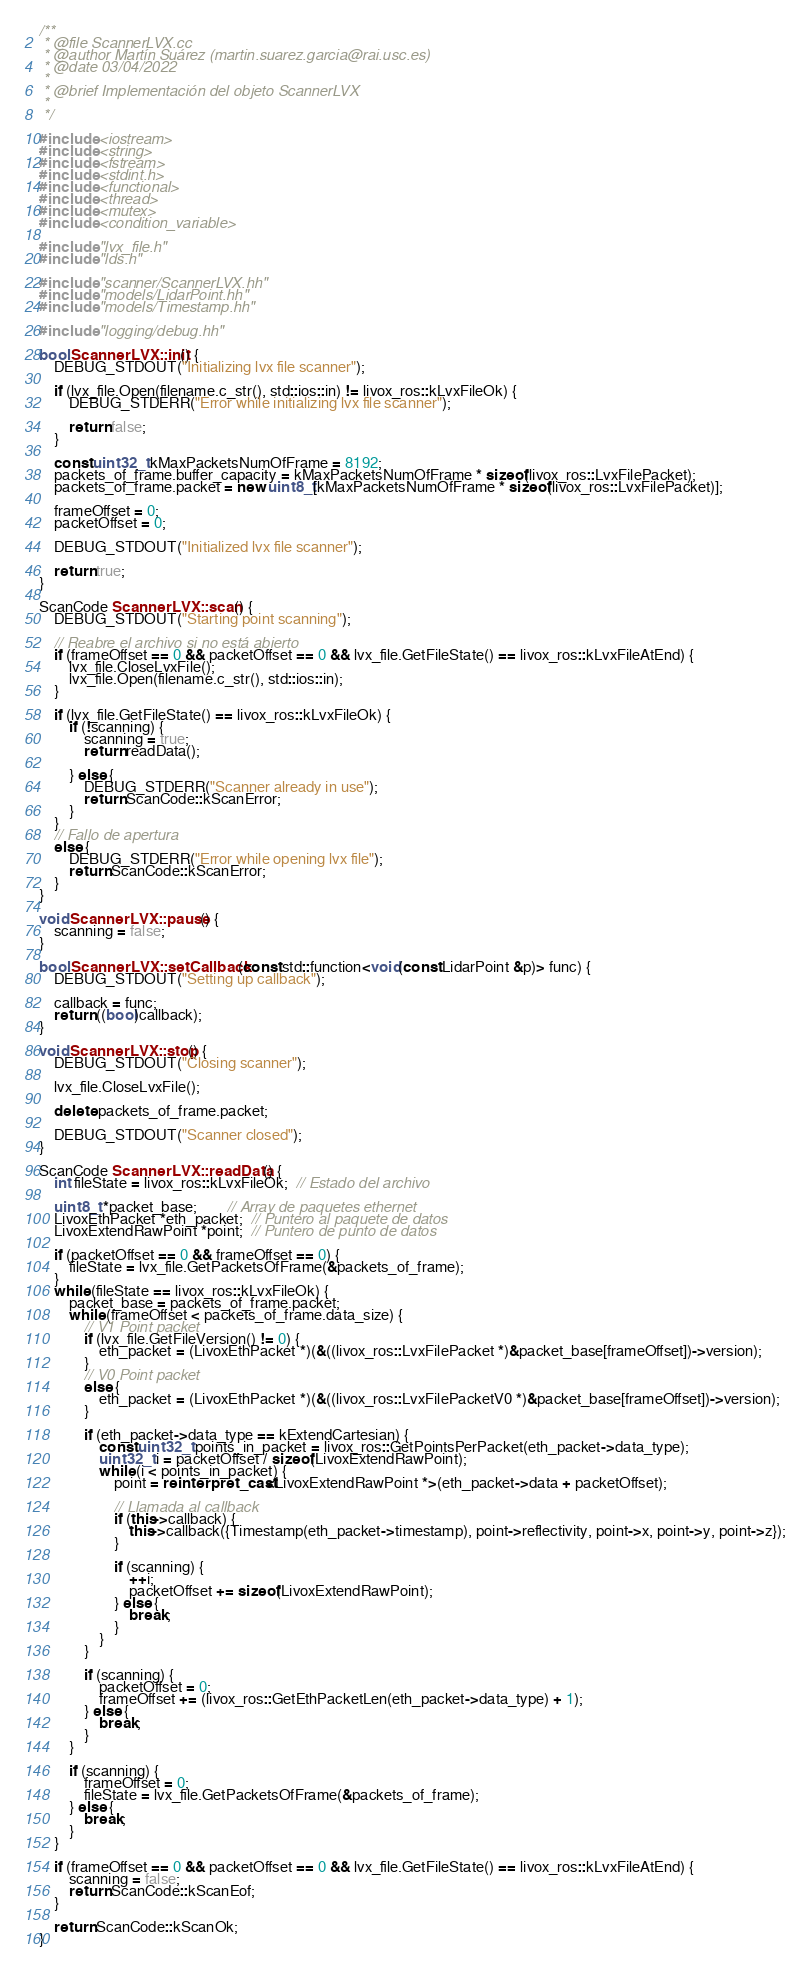Convert code to text. <code><loc_0><loc_0><loc_500><loc_500><_C++_>/**
 * @file ScannerLVX.cc
 * @author Martín Suárez (martin.suarez.garcia@rai.usc.es)
 * @date 03/04/2022
 *
 * @brief Implementación del objeto ScannerLVX
 *
 */

#include <iostream>
#include <string>
#include <fstream>
#include <stdint.h>
#include <functional>
#include <thread>
#include <mutex>
#include <condition_variable>

#include "lvx_file.h"
#include "lds.h"

#include "scanner/ScannerLVX.hh"
#include "models/LidarPoint.hh"
#include "models/Timestamp.hh"

#include "logging/debug.hh"

bool ScannerLVX::init() {
    DEBUG_STDOUT("Initializing lvx file scanner");

    if (lvx_file.Open(filename.c_str(), std::ios::in) != livox_ros::kLvxFileOk) {
        DEBUG_STDERR("Error while initializing lvx file scanner");

        return false;
    }

    const uint32_t kMaxPacketsNumOfFrame = 8192;
    packets_of_frame.buffer_capacity = kMaxPacketsNumOfFrame * sizeof(livox_ros::LvxFilePacket);
    packets_of_frame.packet = new uint8_t[kMaxPacketsNumOfFrame * sizeof(livox_ros::LvxFilePacket)];

    frameOffset = 0;
    packetOffset = 0;

    DEBUG_STDOUT("Initialized lvx file scanner");

    return true;
}

ScanCode ScannerLVX::scan() {
    DEBUG_STDOUT("Starting point scanning");

    // Reabre el archivo si no está abierto
    if (frameOffset == 0 && packetOffset == 0 && lvx_file.GetFileState() == livox_ros::kLvxFileAtEnd) {
        lvx_file.CloseLvxFile();
        lvx_file.Open(filename.c_str(), std::ios::in);
    }

    if (lvx_file.GetFileState() == livox_ros::kLvxFileOk) {
        if (!scanning) {
            scanning = true;
            return readData();

        } else {
            DEBUG_STDERR("Scanner already in use");
            return ScanCode::kScanError;
        }
    }
    // Fallo de apertura
    else {
        DEBUG_STDERR("Error while opening lvx file");
        return ScanCode::kScanError;
    }
}

void ScannerLVX::pause() {
    scanning = false;
}

bool ScannerLVX::setCallback(const std::function<void(const LidarPoint &p)> func) {
    DEBUG_STDOUT("Setting up callback");

    callback = func;
    return ((bool)callback);
}

void ScannerLVX::stop() {
    DEBUG_STDOUT("Closing scanner");

    lvx_file.CloseLvxFile();

    delete packets_of_frame.packet;

    DEBUG_STDOUT("Scanner closed");
}

ScanCode ScannerLVX::readData() {
    int fileState = livox_ros::kLvxFileOk;  // Estado del archivo

    uint8_t *packet_base;        // Array de paquetes ethernet
    LivoxEthPacket *eth_packet;  // Puntero al paquete de datos
    LivoxExtendRawPoint *point;  // Puntero de punto de datos

    if (packetOffset == 0 && frameOffset == 0) {
        fileState = lvx_file.GetPacketsOfFrame(&packets_of_frame);
    }
    while (fileState == livox_ros::kLvxFileOk) {
        packet_base = packets_of_frame.packet;
        while (frameOffset < packets_of_frame.data_size) {
            // V1 Point packet
            if (lvx_file.GetFileVersion() != 0) {
                eth_packet = (LivoxEthPacket *)(&((livox_ros::LvxFilePacket *)&packet_base[frameOffset])->version);
            }
            // V0 Point packet
            else {
                eth_packet = (LivoxEthPacket *)(&((livox_ros::LvxFilePacketV0 *)&packet_base[frameOffset])->version);
            }

            if (eth_packet->data_type == kExtendCartesian) {
                const uint32_t points_in_packet = livox_ros::GetPointsPerPacket(eth_packet->data_type);
                uint32_t i = packetOffset / sizeof(LivoxExtendRawPoint);
                while (i < points_in_packet) {
                    point = reinterpret_cast<LivoxExtendRawPoint *>(eth_packet->data + packetOffset);

                    // Llamada al callback
                    if (this->callback) {
                        this->callback({Timestamp(eth_packet->timestamp), point->reflectivity, point->x, point->y, point->z});
                    }

                    if (scanning) {
                        ++i;
                        packetOffset += sizeof(LivoxExtendRawPoint);
                    } else {
                        break;
                    }
                }
            }

            if (scanning) {
                packetOffset = 0;
                frameOffset += (livox_ros::GetEthPacketLen(eth_packet->data_type) + 1);
            } else {
                break;
            }
        }

        if (scanning) {
            frameOffset = 0;
            fileState = lvx_file.GetPacketsOfFrame(&packets_of_frame);
        } else {
            break;
        }
    }

    if (frameOffset == 0 && packetOffset == 0 && lvx_file.GetFileState() == livox_ros::kLvxFileAtEnd) {
        scanning = false;
        return ScanCode::kScanEof;
    }

    return ScanCode::kScanOk;
}</code> 